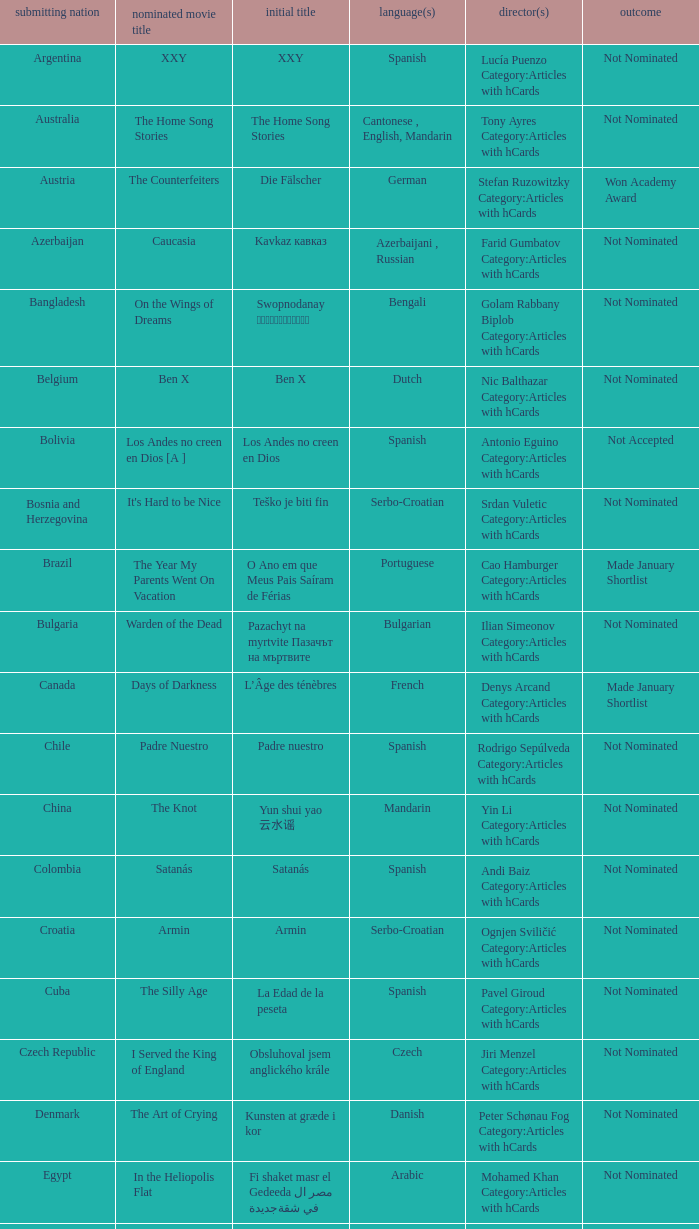What country submitted the movie the orphanage? Spain. 